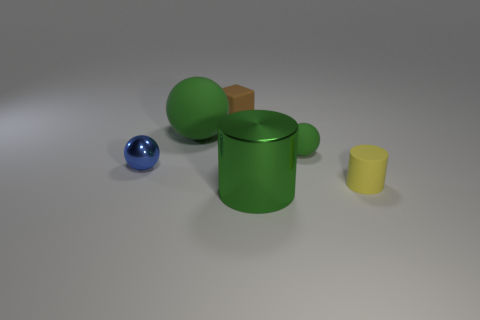Could you describe the textures visible in the image? Certainly! The textures in the image showcase a mix of smooth and matte finishes. The green and blue spherical objects have a shiny, smooth surface suggesting a polished texture. In contrast, the cube and cylinder appear to have a matte surface, which diffuses light more evenly and gives off a softer look. 